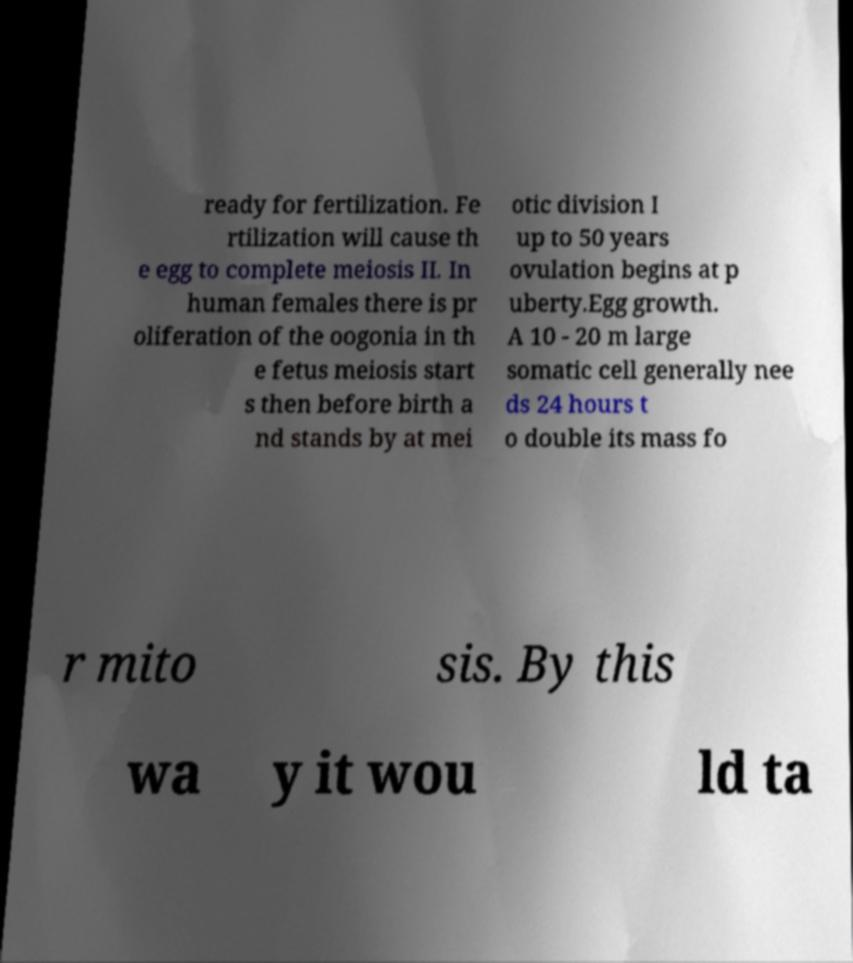Can you accurately transcribe the text from the provided image for me? ready for fertilization. Fe rtilization will cause th e egg to complete meiosis II. In human females there is pr oliferation of the oogonia in th e fetus meiosis start s then before birth a nd stands by at mei otic division I up to 50 years ovulation begins at p uberty.Egg growth. A 10 - 20 m large somatic cell generally nee ds 24 hours t o double its mass fo r mito sis. By this wa y it wou ld ta 